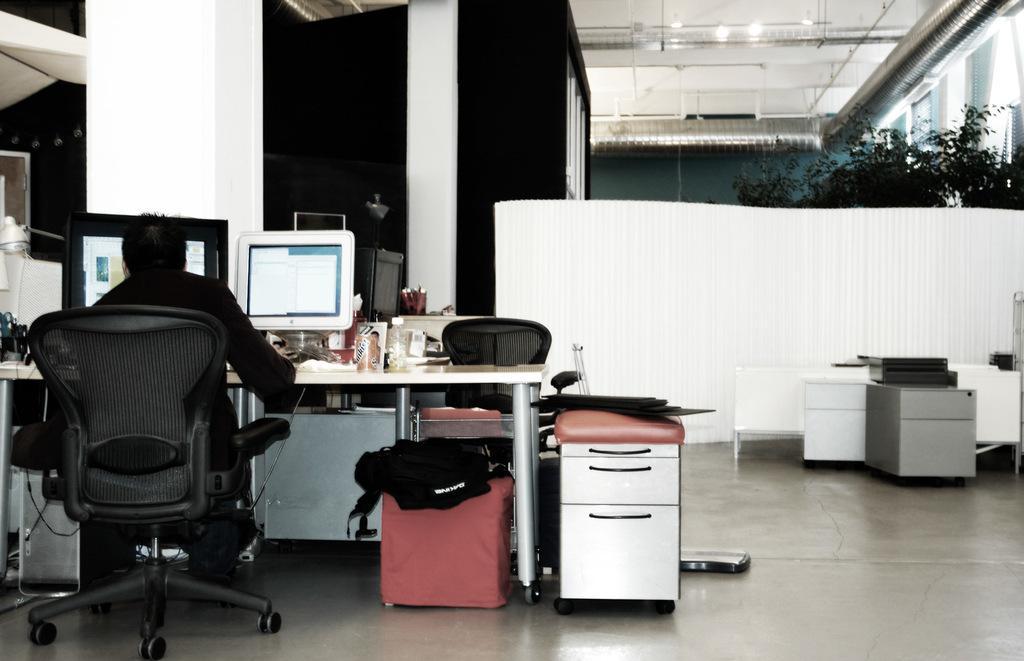In one or two sentences, can you explain what this image depicts? In this picture we can see a person sitting on a chair infront of a computer and on the table we can see tin,glass. Under the table there is a bag. This is a desk. this is a floor. At the top this is a light and ceiling. 